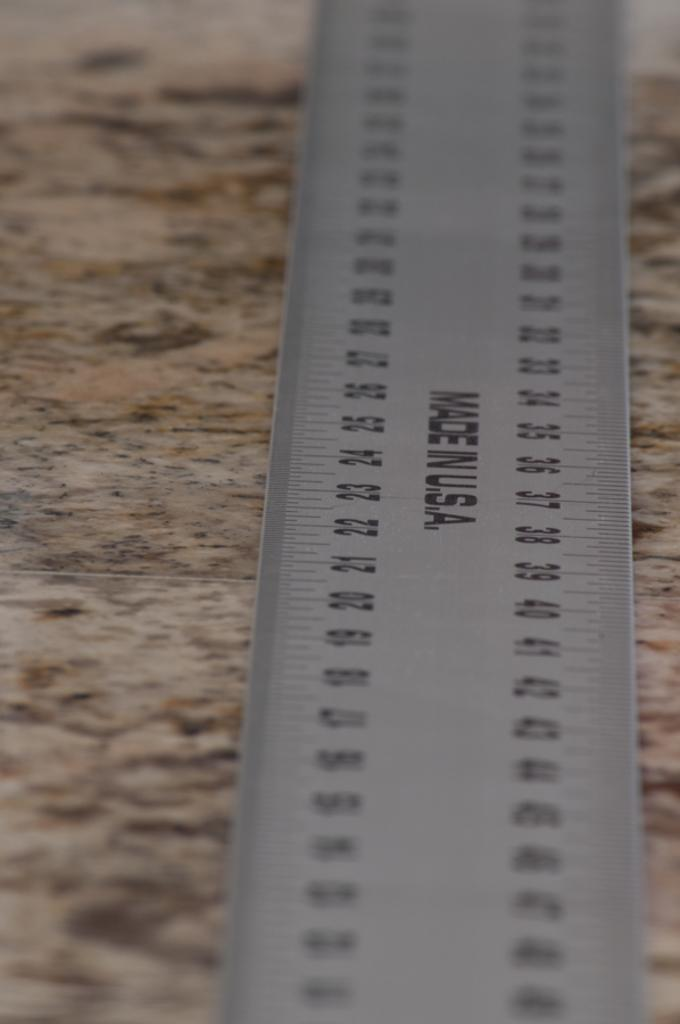<image>
Provide a brief description of the given image. A metal ruler made in the USA sits on a counter top. 